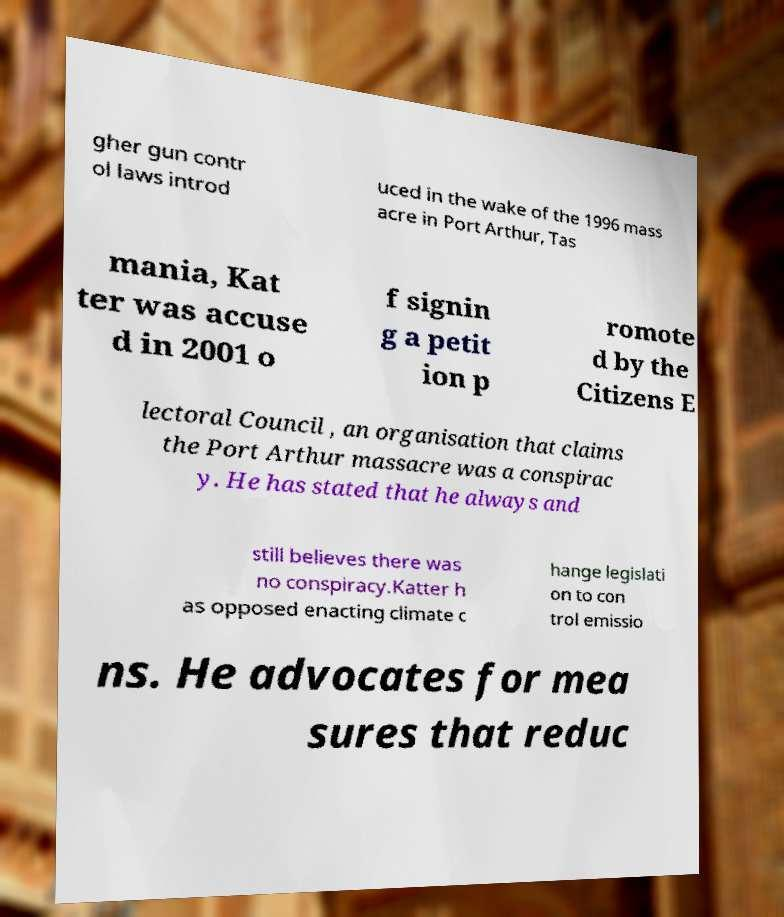There's text embedded in this image that I need extracted. Can you transcribe it verbatim? gher gun contr ol laws introd uced in the wake of the 1996 mass acre in Port Arthur, Tas mania, Kat ter was accuse d in 2001 o f signin g a petit ion p romote d by the Citizens E lectoral Council , an organisation that claims the Port Arthur massacre was a conspirac y. He has stated that he always and still believes there was no conspiracy.Katter h as opposed enacting climate c hange legislati on to con trol emissio ns. He advocates for mea sures that reduc 